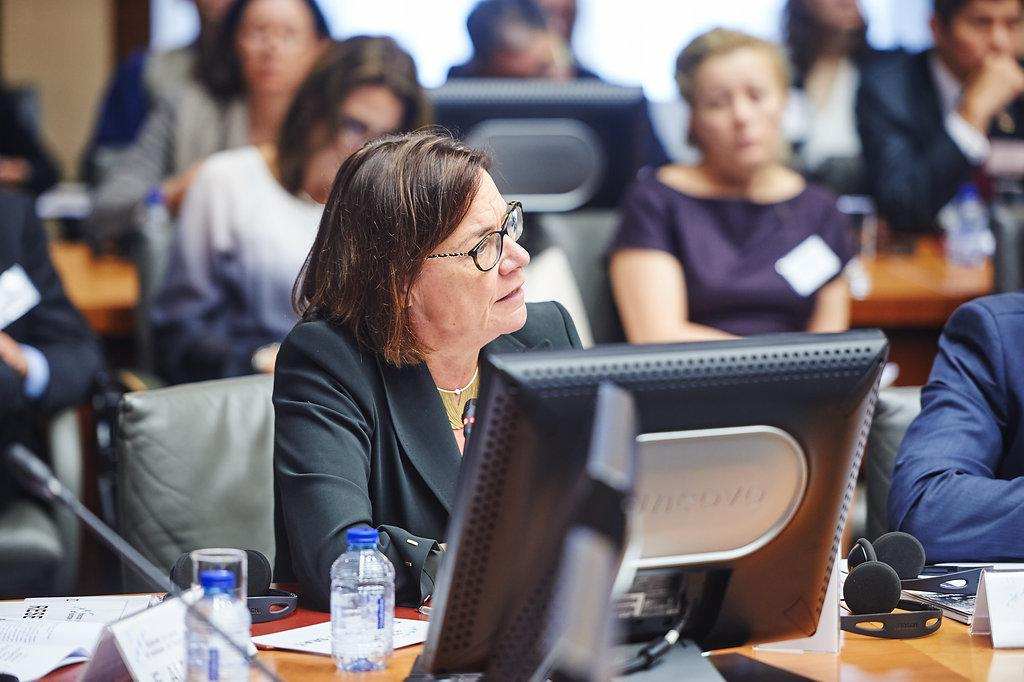What are the people in the image doing? The people in the image are sitting on chairs. What objects can be seen on the table in the image? There are bottles, a monitor, a mic, and a headphone on the table in the image. Can you describe the appearance of one of the people in the image? A person is wearing glasses in the image. What type of car is parked in front of the table in the image? There is no car present in the image; it only shows people sitting on chairs and objects on a table. 